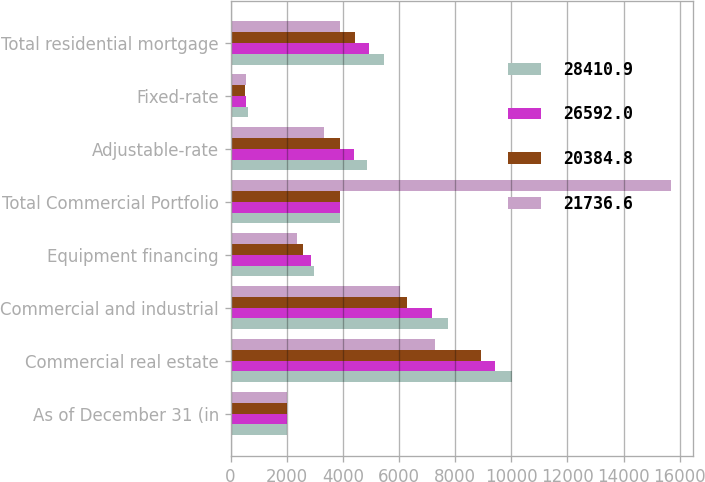Convert chart. <chart><loc_0><loc_0><loc_500><loc_500><stacked_bar_chart><ecel><fcel>As of December 31 (in<fcel>Commercial real estate<fcel>Commercial and industrial<fcel>Equipment financing<fcel>Total Commercial Portfolio<fcel>Adjustable-rate<fcel>Fixed-rate<fcel>Total residential mortgage<nl><fcel>28410.9<fcel>2015<fcel>10028.8<fcel>7748.7<fcel>2973.3<fcel>3895.3<fcel>4851.2<fcel>605.8<fcel>5457<nl><fcel>26592<fcel>2014<fcel>9404.3<fcel>7189.6<fcel>2865.5<fcel>3895.3<fcel>4393.8<fcel>538.2<fcel>4932<nl><fcel>20384.8<fcel>2013<fcel>8921.6<fcel>6302.1<fcel>2593.1<fcel>3895.3<fcel>3895.3<fcel>521.3<fcel>4416.6<nl><fcel>21736.6<fcel>2012<fcel>7294.2<fcel>6047.7<fcel>2352.3<fcel>15694.2<fcel>3335.2<fcel>550.9<fcel>3886.1<nl></chart> 